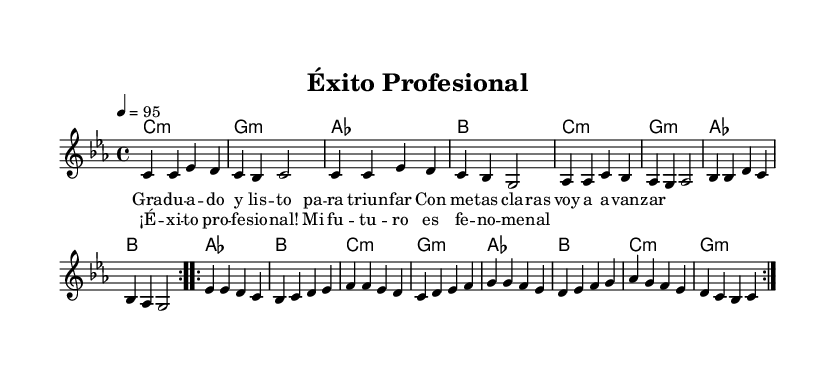What is the time signature of this music? The time signature is indicated at the beginning of the score, where "4/4" appears, which means there are four beats in each measure and the quarter note receives one beat.
Answer: 4/4 What is the key signature of this music? The key signature is noted at the beginning, in the section labeled "global." It indicates a C minor key with three flats (B flat, E flat, and A flat).
Answer: C minor What is the tempo marking specified? The tempo marking is located towards the beginning of the score and shows "4 = 95," which indicates that the tempo is set to 95 beats per minute.
Answer: 95 Which section includes the lyrics "¡Éxito profesional!"? The lyrics are organized in separate parts in the score, and the phrase "¡Éxito profesional!" appears in the chorus section's lyrics.
Answer: Chorus How many times is the melody section repeated? The melody section is marked with the repeat symbol "repeat volta" which indicates that it is played twice.
Answer: 2 What are the chord names for the first measure? The chord names are represented below the staff, with the first measure indicating "C minor" as per the chord notation given.
Answer: C minor What is the overall style of this music based on its characteristics? Given the upbeat tempo, the lyrics' celebratory nature, and the reggaeton rhythmic patterns, it can be identified as a Latin energetic reggaeton track, tailored for celebrations.
Answer: Reggaeton 